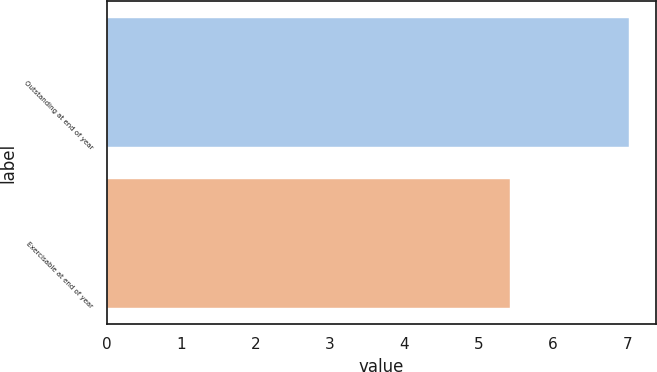Convert chart to OTSL. <chart><loc_0><loc_0><loc_500><loc_500><bar_chart><fcel>Outstanding at end of year<fcel>Exercisable at end of year<nl><fcel>7.03<fcel>5.42<nl></chart> 